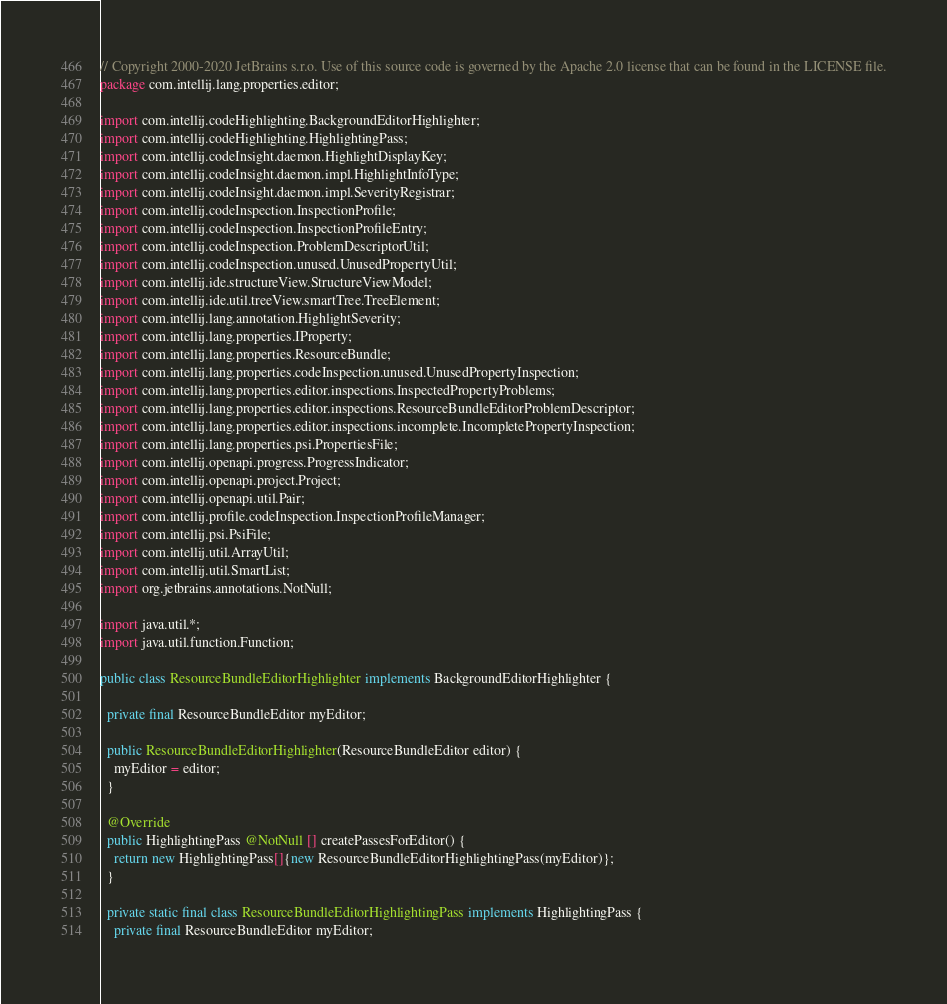<code> <loc_0><loc_0><loc_500><loc_500><_Java_>// Copyright 2000-2020 JetBrains s.r.o. Use of this source code is governed by the Apache 2.0 license that can be found in the LICENSE file.
package com.intellij.lang.properties.editor;

import com.intellij.codeHighlighting.BackgroundEditorHighlighter;
import com.intellij.codeHighlighting.HighlightingPass;
import com.intellij.codeInsight.daemon.HighlightDisplayKey;
import com.intellij.codeInsight.daemon.impl.HighlightInfoType;
import com.intellij.codeInsight.daemon.impl.SeverityRegistrar;
import com.intellij.codeInspection.InspectionProfile;
import com.intellij.codeInspection.InspectionProfileEntry;
import com.intellij.codeInspection.ProblemDescriptorUtil;
import com.intellij.codeInspection.unused.UnusedPropertyUtil;
import com.intellij.ide.structureView.StructureViewModel;
import com.intellij.ide.util.treeView.smartTree.TreeElement;
import com.intellij.lang.annotation.HighlightSeverity;
import com.intellij.lang.properties.IProperty;
import com.intellij.lang.properties.ResourceBundle;
import com.intellij.lang.properties.codeInspection.unused.UnusedPropertyInspection;
import com.intellij.lang.properties.editor.inspections.InspectedPropertyProblems;
import com.intellij.lang.properties.editor.inspections.ResourceBundleEditorProblemDescriptor;
import com.intellij.lang.properties.editor.inspections.incomplete.IncompletePropertyInspection;
import com.intellij.lang.properties.psi.PropertiesFile;
import com.intellij.openapi.progress.ProgressIndicator;
import com.intellij.openapi.project.Project;
import com.intellij.openapi.util.Pair;
import com.intellij.profile.codeInspection.InspectionProfileManager;
import com.intellij.psi.PsiFile;
import com.intellij.util.ArrayUtil;
import com.intellij.util.SmartList;
import org.jetbrains.annotations.NotNull;

import java.util.*;
import java.util.function.Function;

public class ResourceBundleEditorHighlighter implements BackgroundEditorHighlighter {

  private final ResourceBundleEditor myEditor;

  public ResourceBundleEditorHighlighter(ResourceBundleEditor editor) {
    myEditor = editor;
  }

  @Override
  public HighlightingPass @NotNull [] createPassesForEditor() {
    return new HighlightingPass[]{new ResourceBundleEditorHighlightingPass(myEditor)};
  }

  private static final class ResourceBundleEditorHighlightingPass implements HighlightingPass {
    private final ResourceBundleEditor myEditor;
</code> 